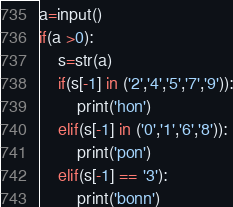<code> <loc_0><loc_0><loc_500><loc_500><_Python_>a=input()
if(a >0):
	s=str(a)
	if(s[-1] in ('2','4','5','7','9')):
		print('hon')
	elif(s[-1] in ('0','1','6','8')):
		print('pon')
	elif(s[-1] == '3'):
		print('bonn')</code> 